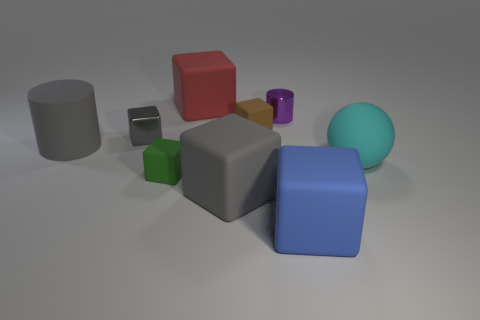Do the matte thing to the left of the tiny green matte cube and the metallic object to the left of the purple metal cylinder have the same color?
Provide a succinct answer. Yes. What size is the gray rubber object that is the same shape as the gray shiny object?
Ensure brevity in your answer.  Large. How many other objects are the same shape as the blue thing?
Make the answer very short. 5. Does the blue rubber object have the same shape as the tiny purple object?
Your answer should be very brief. No. How many objects are either big rubber cubes in front of the gray matte cylinder or objects that are in front of the large red rubber block?
Ensure brevity in your answer.  8. What number of things are tiny metal cylinders or big blue matte blocks?
Give a very brief answer. 2. There is a rubber object that is on the right side of the blue matte object; what number of brown matte things are on the left side of it?
Your answer should be very brief. 1. How many other things are the same size as the blue rubber thing?
Offer a very short reply. 4. There is a matte cube that is the same color as the rubber cylinder; what size is it?
Your response must be concise. Large. There is a large thing that is behind the big cylinder; is its shape the same as the big blue rubber object?
Your answer should be compact. Yes. 